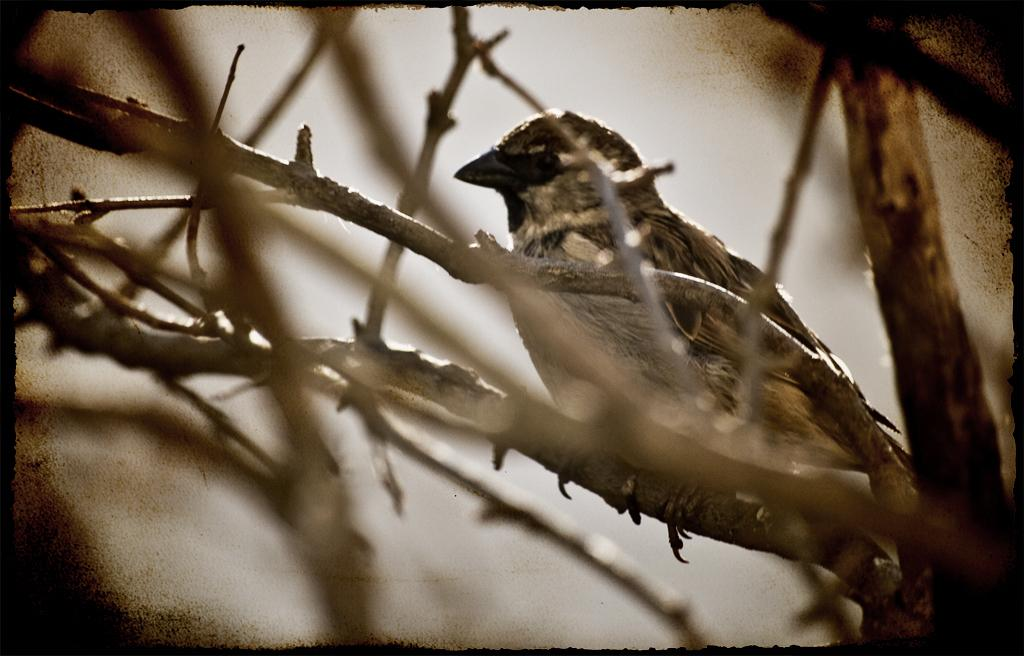What type of animal can be seen in the image? There is a bird in the image. Where is the bird located in the image? The bird is sitting on a dried stem. How many bears can be seen in the image? There are no bears present in the image; it features a bird sitting on a dried stem. What angle does the bird's beak form with the stem? The image does not provide enough detail to determine the angle of the bird's beak in relation to the stem. 